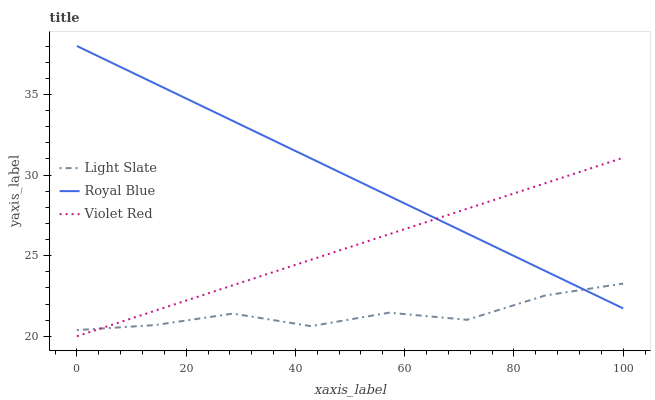Does Violet Red have the minimum area under the curve?
Answer yes or no. No. Does Violet Red have the maximum area under the curve?
Answer yes or no. No. Is Royal Blue the smoothest?
Answer yes or no. No. Is Royal Blue the roughest?
Answer yes or no. No. Does Royal Blue have the lowest value?
Answer yes or no. No. Does Violet Red have the highest value?
Answer yes or no. No. 